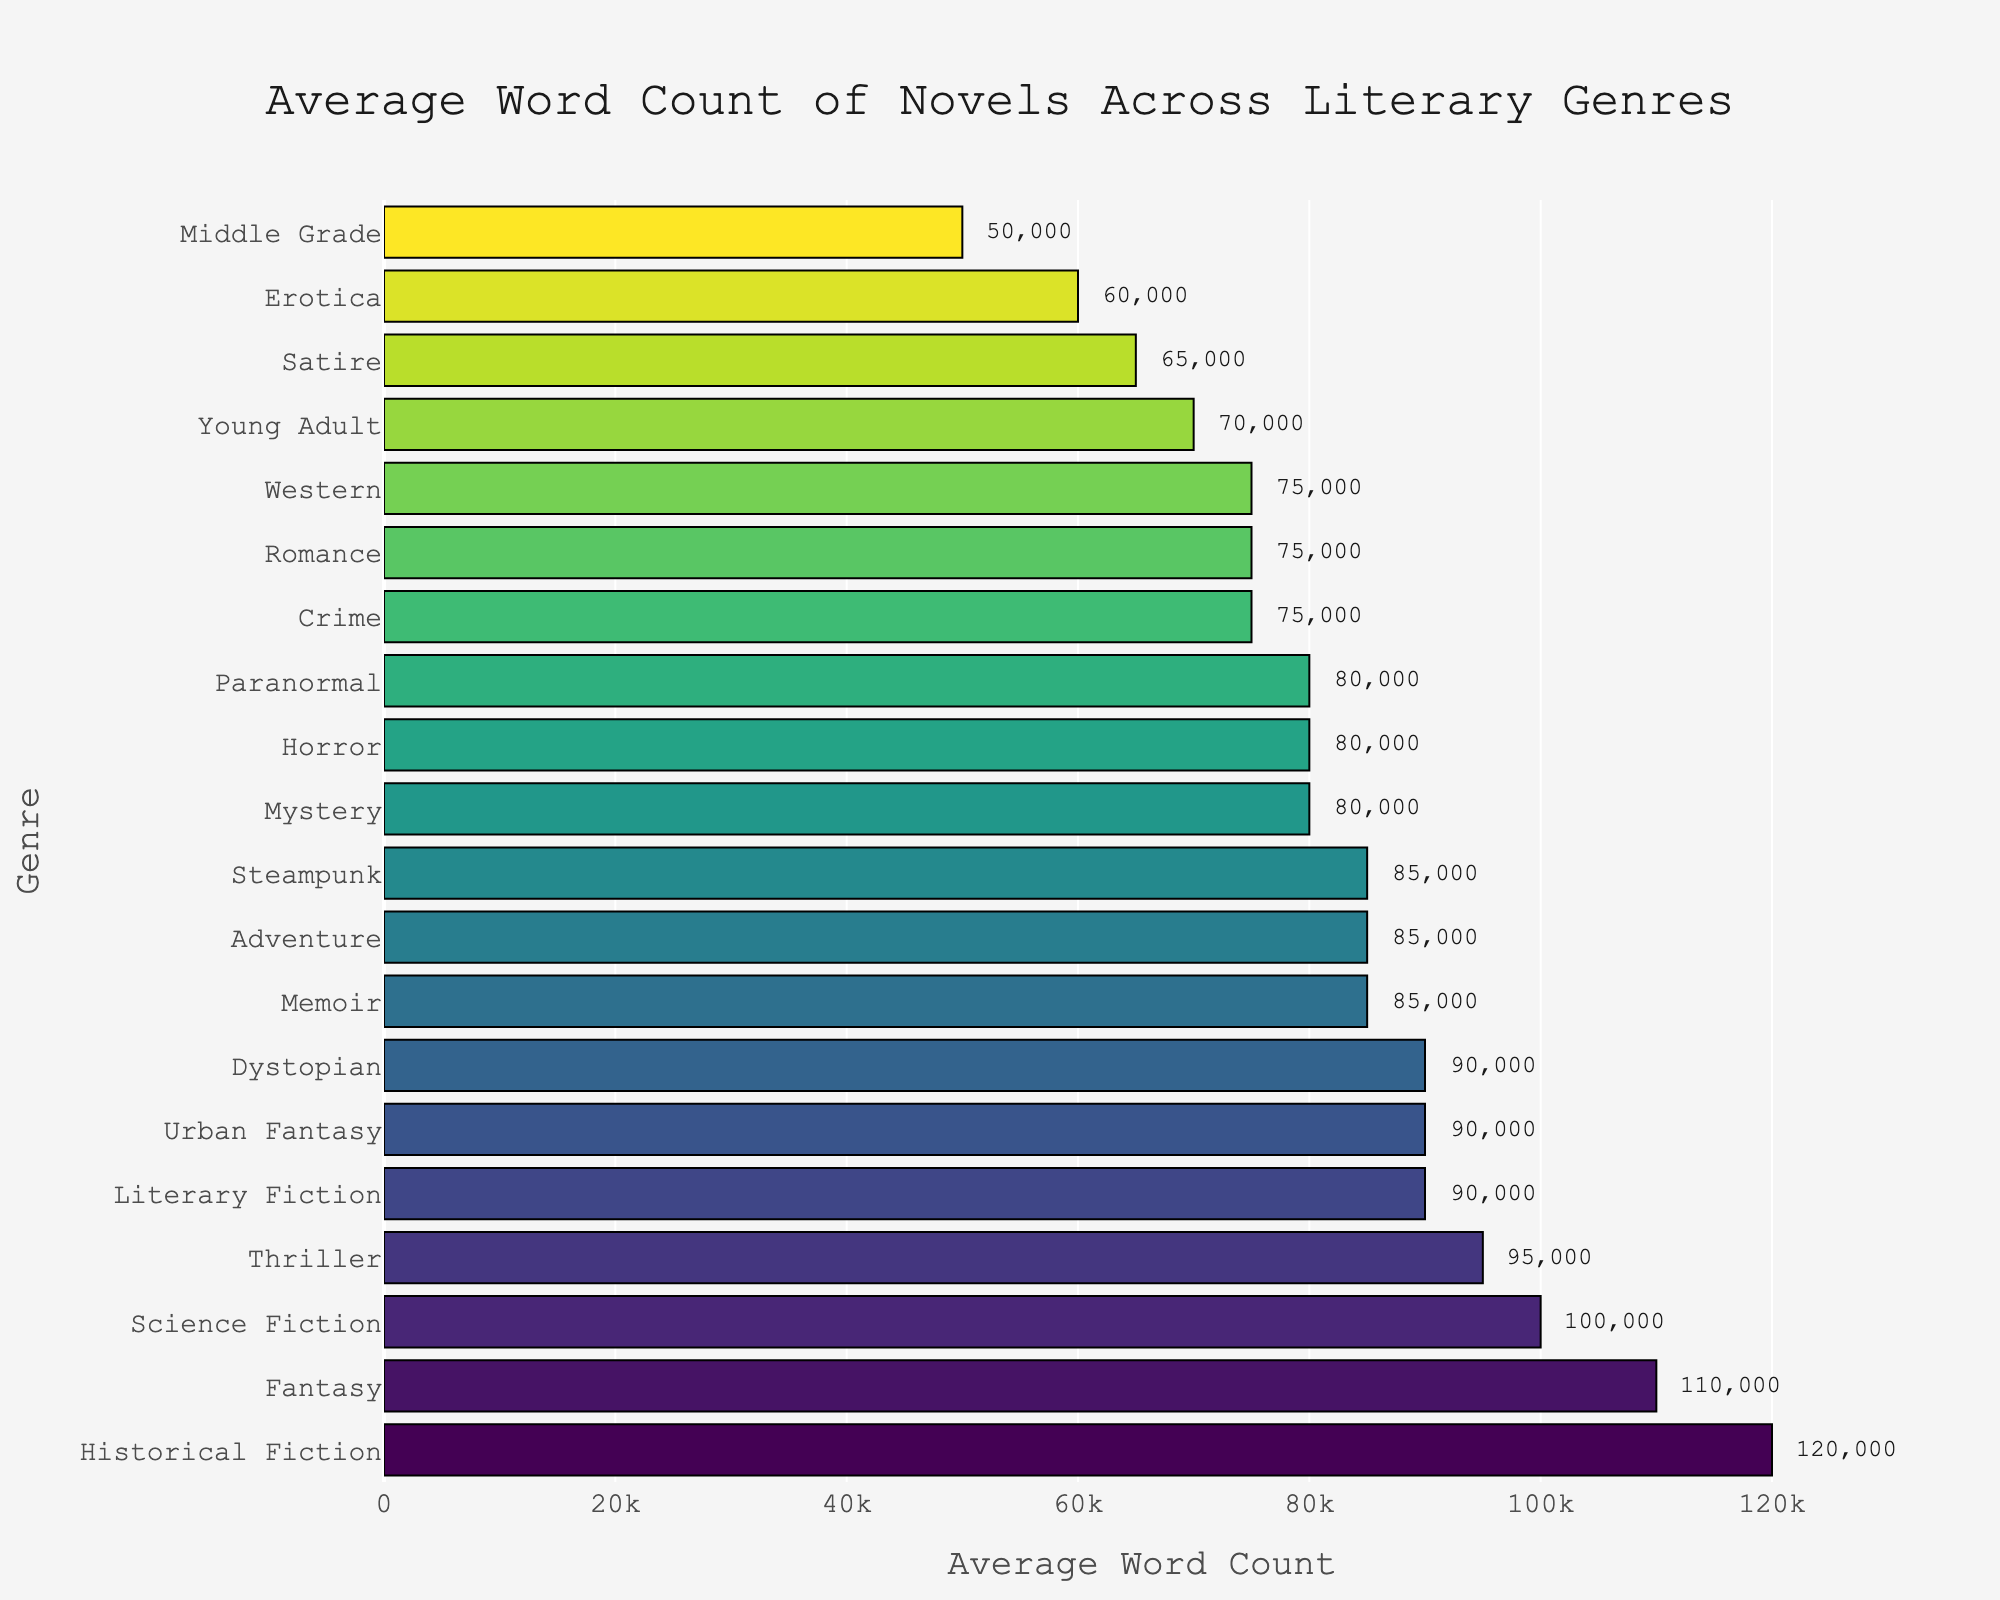Which genre has the highest average word count? Observe the bar chart to find the tallest bar with the highest value on the x-axis. Historical Fiction has the highest average word count at 120,000.
Answer: Historical Fiction Which genres have an average word count between 80,000 to 90,000? Identify bars with values within the specified range on the x-axis. Mystery, Horror, Memoir, Dystopian, Paranormal, Adventure, Steampunk, and Urban Fantasy fall within the 80,000 to 90,000 range.
Answer: Mystery, Horror, Memoir, Dystopian, Paranormal, Adventure, Steampunk, Urban Fantasy How much higher is the average word count of Fantasy compared to Romance? Locate the bars for Fantasy and Romance and subtract Romance's word count from Fantasy's. Fantasy: 110,000, Romance: 75,000. Therefore, 110,000 - 75,000 = 35,000.
Answer: 35,000 Which genre has a lower average word count, Satire, or Crime? Compare the lengths of the bars for Satire and Crime. Satire has 65,000, while Crime has 75,000. Therefore, Satire has a lower average word count.
Answer: Satire Are there more genres with an average word count above or below 85,000? Count the number of bars above and below 85,000 on the x-axis. There are 9 genres above 85,000 (including 85,000) and 11 genres below 85,000. Thus, there are more genres below 85,000.
Answer: Below What is the difference in average word count between the genre with the lowest and highest values? Identify the shortest and tallest bars to find the genres with the lowest and highest average word counts. Historical Fiction has 120,000, and Middle Grade has 50,000. Therefore, 120,000 - 50,000 = 70,000.
Answer: 70,000 Which genre is closest to having an average word count of 75,000? Locate the bars around the 75,000 mark. Romance, Western, and Crime all have an exact average word count of 75,000.
Answer: Romance, Western, and Crime Is the average word count of Dystopian closer to that of Memoir or Science Fiction? Calculate the differences: Memoir (85,000) to Dystopian (90,000) = 5,000; Science Fiction (100,000) to Dystopian (90,000) = 10,000. Dystopian is closer to Memoir.
Answer: Memoir 